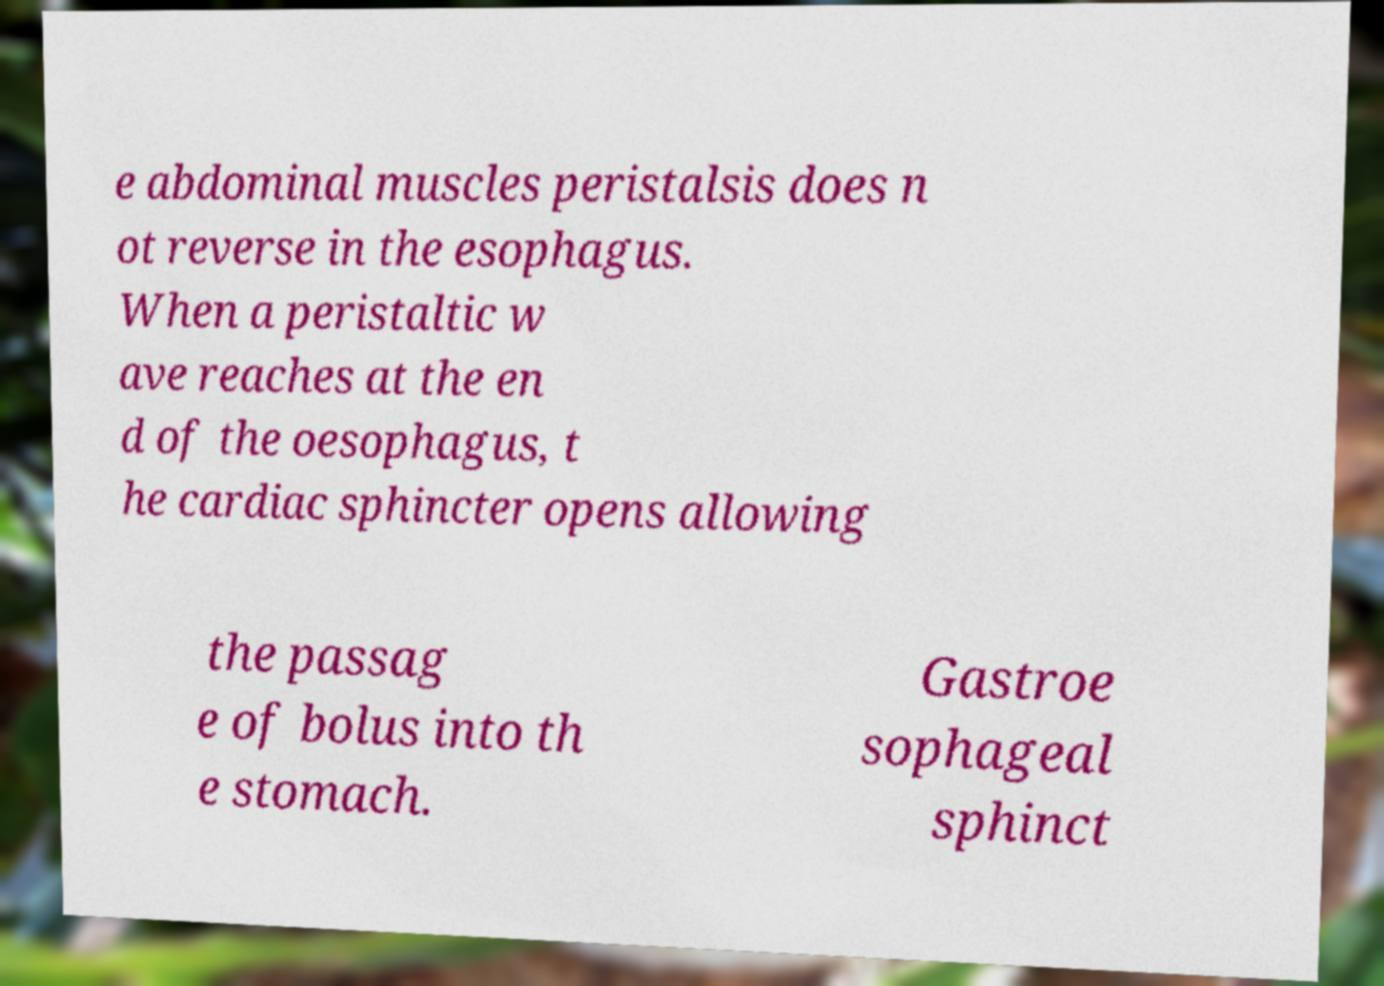Could you extract and type out the text from this image? e abdominal muscles peristalsis does n ot reverse in the esophagus. When a peristaltic w ave reaches at the en d of the oesophagus, t he cardiac sphincter opens allowing the passag e of bolus into th e stomach. Gastroe sophageal sphinct 